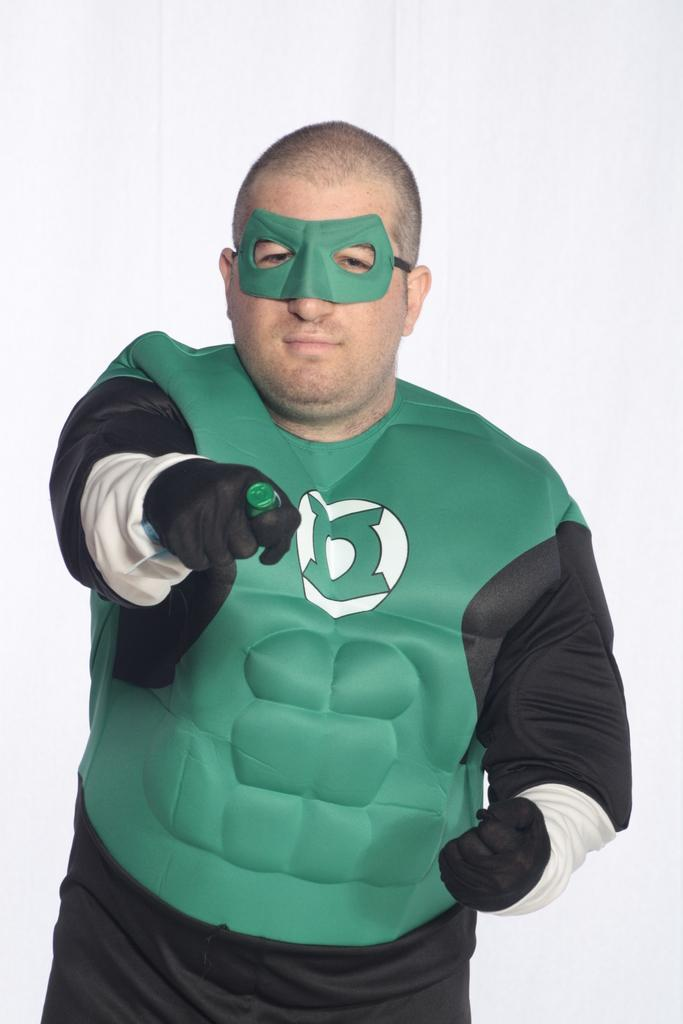Who or what is present in the image? There is a person in the image. Can you describe the appearance of the person? The person is wearing a dramatic costume. What caused the person to laugh in the image? There is no indication in the image that the person is laughing or that any cause for laughter is present. 